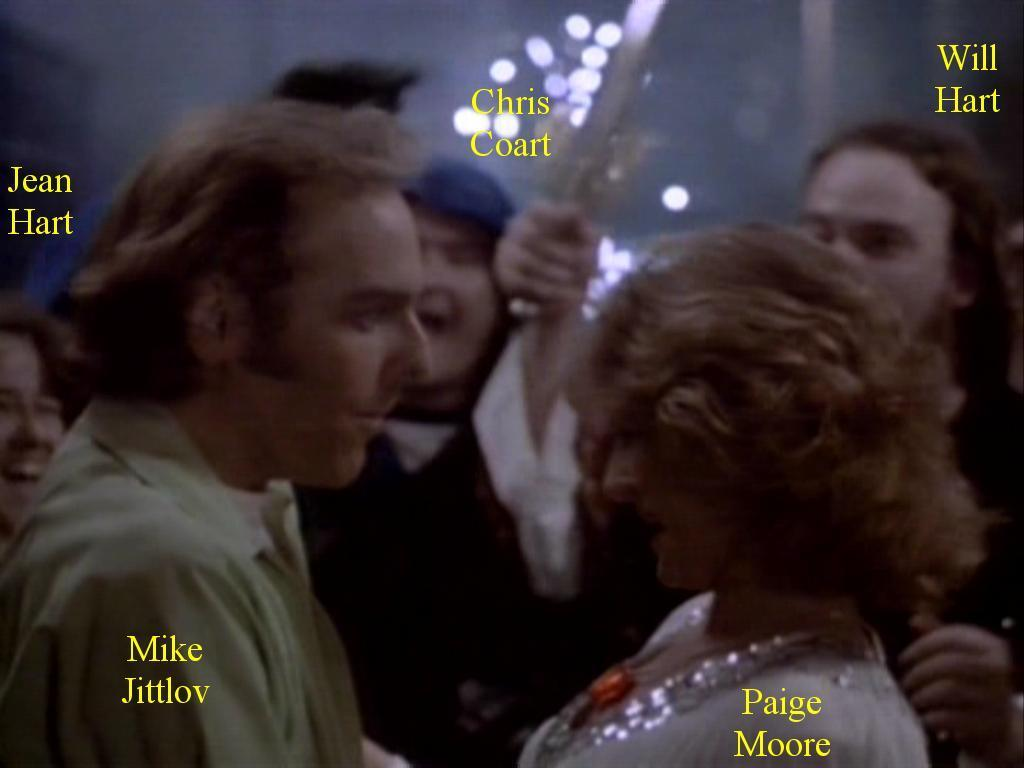How many people can be seen in the image? There are a few people in the image. What else is visible in the image besides the people? There is some text visible in the image. What type of body is visible in the image? There is no body present in the image; it only features people and text. 